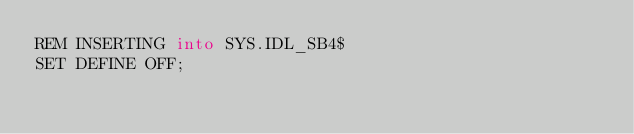<code> <loc_0><loc_0><loc_500><loc_500><_SQL_>REM INSERTING into SYS.IDL_SB4$
SET DEFINE OFF;
</code> 